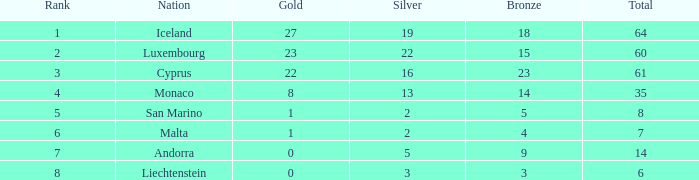How many bronzes for Iceland with over 2 silvers? 18.0. 